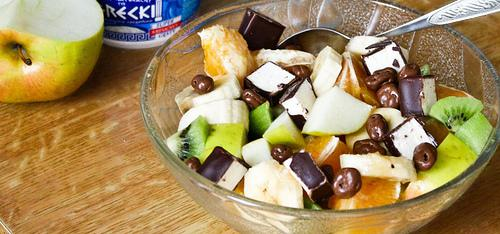Question: what kind of dish is the fruit in?
Choices:
A. A glass bowl.
B. A plastic cup.
C. A plate.
D. A special cup.
Answer with the letter. Answer: A Question: how is the salad being stirred?
Choices:
A. With a silver spoon.
B. With a black spoon.
C. With tongs.
D. With a fork.
Answer with the letter. Answer: A Question: what is in the bowl?
Choices:
A. Garden salad.
B. Soup.
C. Potato salad.
D. Fruit salad.
Answer with the letter. Answer: D Question: what is the green fruit?
Choices:
A. Watermelon.
B. Honeydew.
C. Kiwi.
D. Grapes.
Answer with the letter. Answer: C 